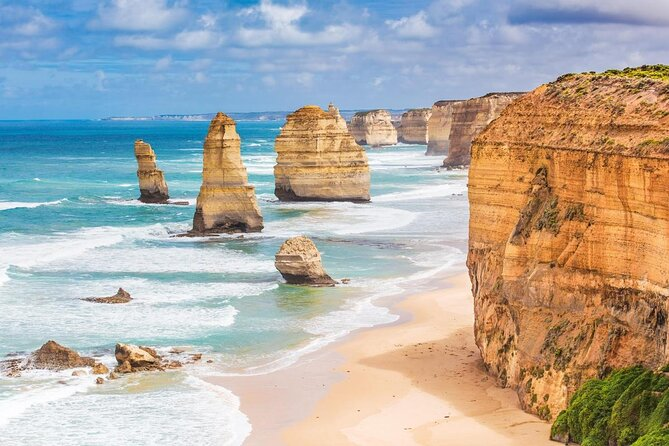What do you think is going on in this snapshot? This image captures the breathtaking view of the Twelve Apostles, a renowned landmark located off the shore of Port Campbell National Park in Victoria, Australia. The Twelve Apostles are a collection of limestone stacks that stand majestically against the backdrop of the deep blue ocean. The stacks, painted in various shades of orange and beige, rise from the ocean, showcasing the raw beauty and power of nature. The image is taken from a high vantage point, providing a panoramic view of the stacks and the surrounding ocean. The sky above is filled with clouds, adding a dramatic touch to the awe-inspiring scene. The overall mood of the photo is one of grandeur and reverence for the natural world. 